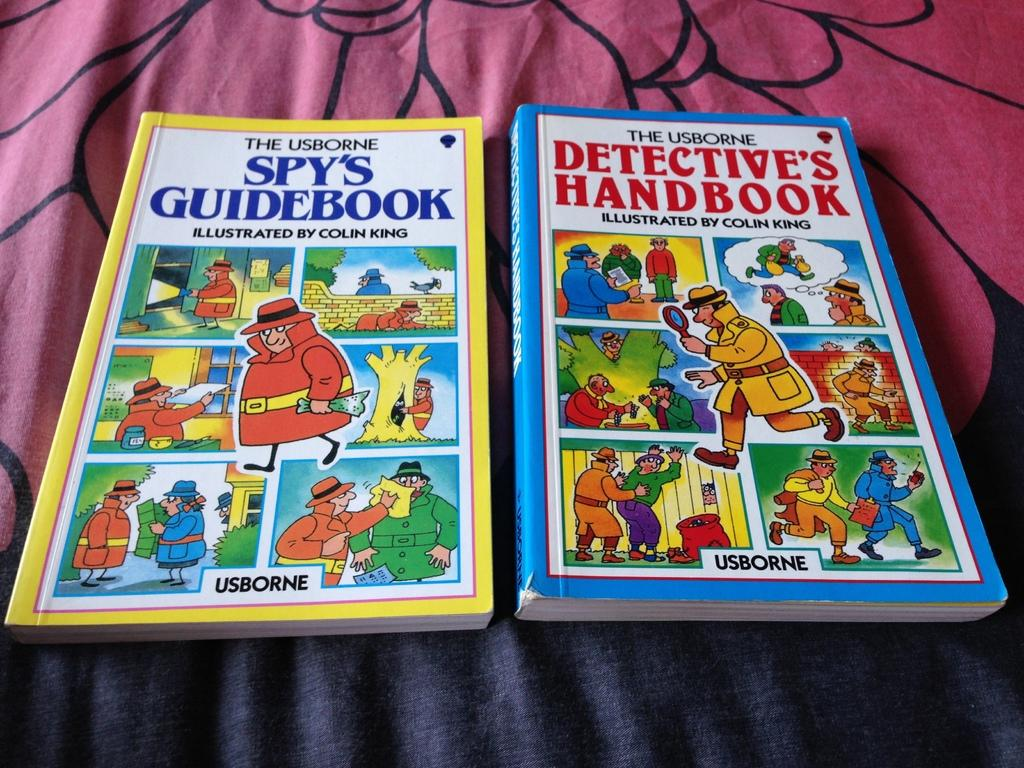<image>
Provide a brief description of the given image. a yellow and blue comic books  with the word Usborne on top. 